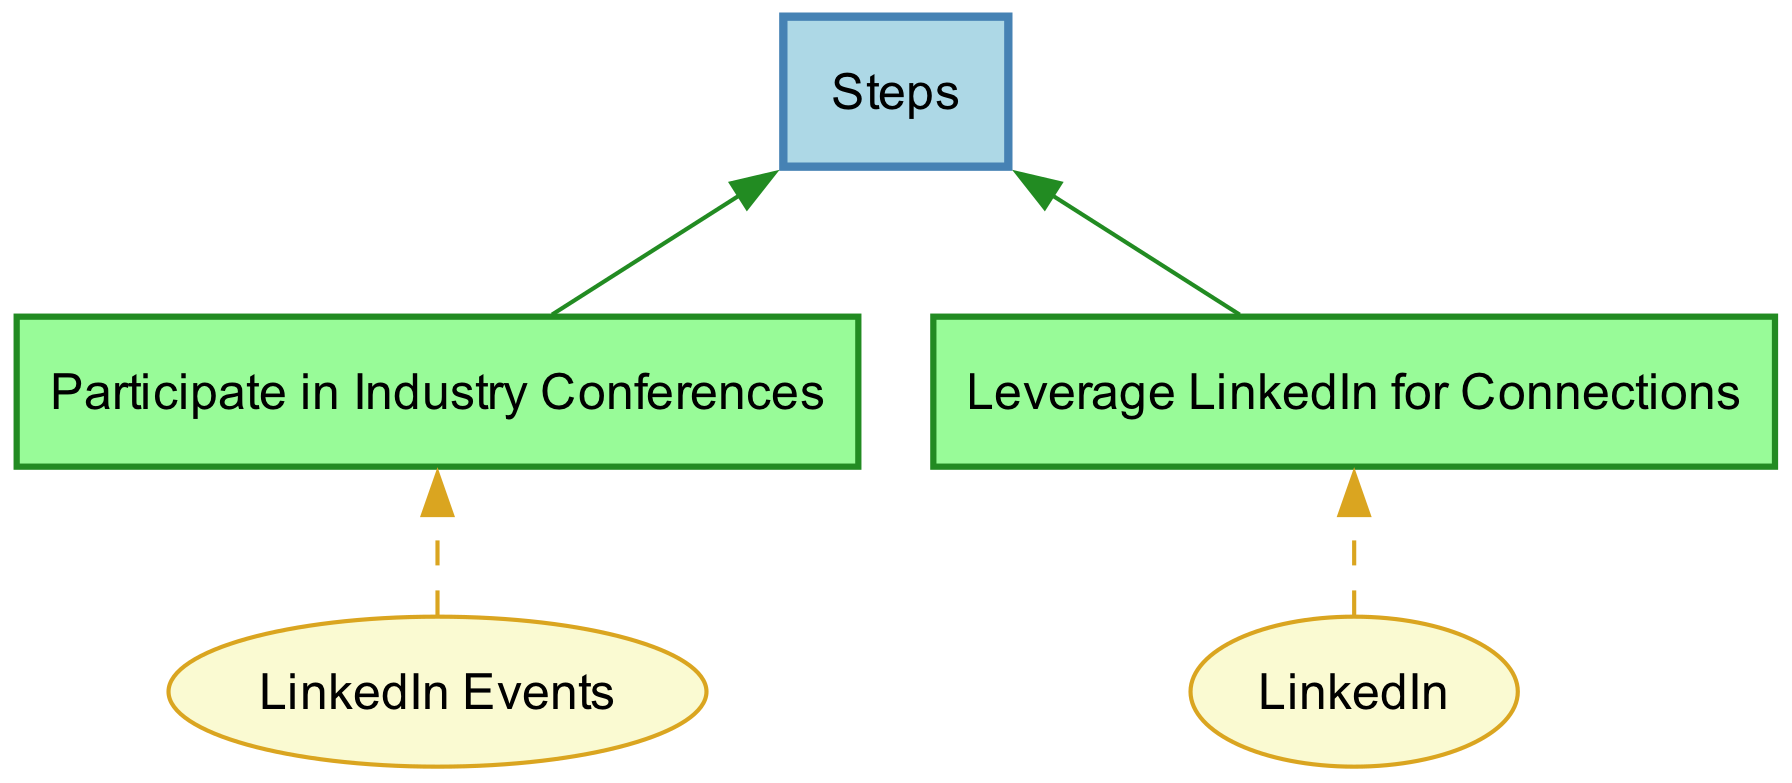What is the first personal development goal listed? The diagram indicates that the first personal development goal is "Enhance Leadership Skills". This can be found directly by scanning the nodes for the goals, and "Enhance Leadership Skills" appears first.
Answer: Enhance Leadership Skills How many steps are associated with the goal of enhancing leadership skills? Reviewing the steps closely, there are three steps listed under the goal "Enhance Leadership Skills": Enroll in a Leadership Workshop, Read 'Leaders Eat Last' by Simon Sinek, and Join a Toastmasters Club. This is easily counted in the diagram.
Answer: 3 What resource is needed to read 'Leaders Eat Last'? By checking the node connected to 'Read 'Leaders Eat Last' by Simon Sinek', it shows 'Local Library or Kindle Store' as the resource required. This is indicated in the diagram where the resource node points to the step.
Answer: Local Library or Kindle Store How many total personal development goals are shown in the diagram? The diagram displays three distinct goals related to personal development: Enhance Leadership Skills, Improve Public Speaking, and Expand Professional Network. Counting these goals gives a total of three.
Answer: 3 Which step requires participating in industry conferences? Identifying the step related to participating in industry conferences, we find it under the goal "Expand Professional Network". The corresponding step is clearly labeled as "Participate in Industry Conferences".
Answer: Participate in Industry Conferences Which resource is common between the steps for improving public speaking and expanding the professional network? Both goals have a common resource of 'LinkedIn' as found in the "Leverage LinkedIn for Connections" step under "Expand Professional Network" and is similar to actions done in relation to speaking events and networking.
Answer: LinkedIn What color represents the nodes for steps in the diagram? The diagram utilizes a light green shade for the step nodes, indicated by the fill color '#98FB98'. This can be confirmed by directly viewing the attributes set for step nodes in the diagram.
Answer: Light Green What is the last step for the goal of improving public speaking? Under the goal "Improve Public Speaking," the last step listed is "Practice at Local Meetup Events." This can be confirmed by navigating to the steps associated with this specific goal in the diagram.
Answer: Practice at Local Meetup Events 